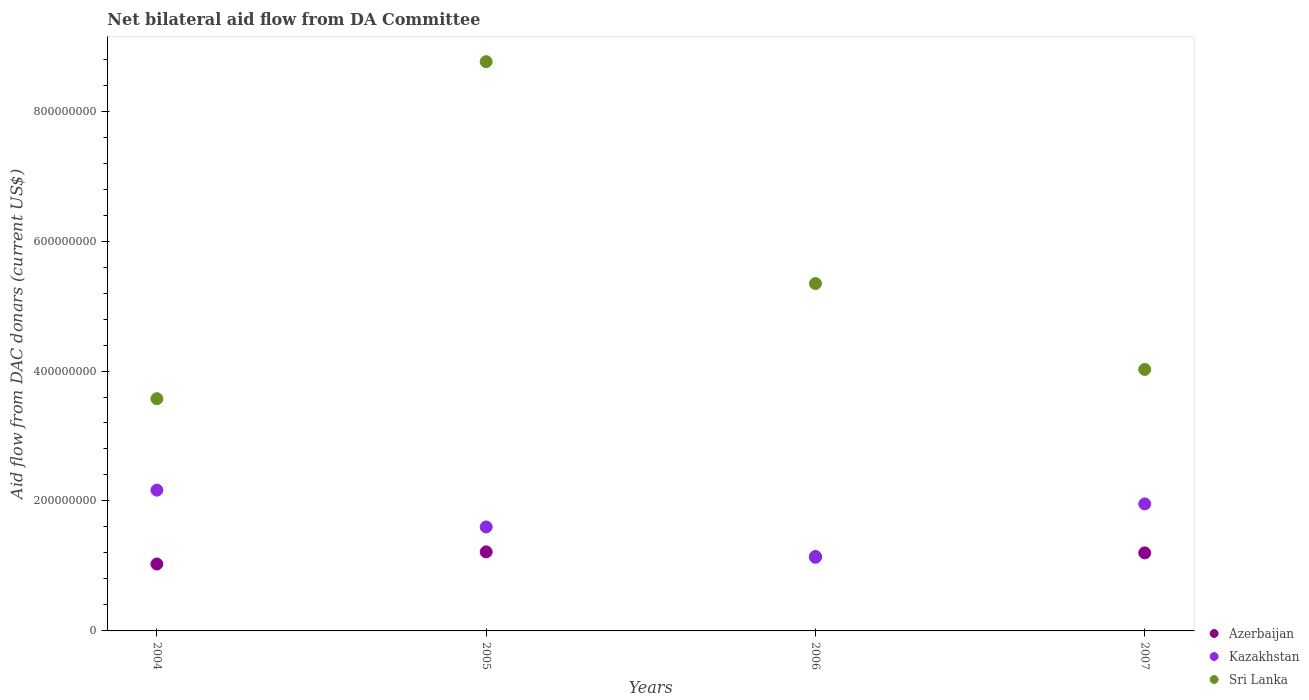How many different coloured dotlines are there?
Your answer should be compact. 3. Is the number of dotlines equal to the number of legend labels?
Keep it short and to the point. Yes. What is the aid flow in in Sri Lanka in 2007?
Give a very brief answer. 4.02e+08. Across all years, what is the maximum aid flow in in Kazakhstan?
Make the answer very short. 2.17e+08. Across all years, what is the minimum aid flow in in Kazakhstan?
Your answer should be very brief. 1.13e+08. What is the total aid flow in in Kazakhstan in the graph?
Your answer should be compact. 6.85e+08. What is the difference between the aid flow in in Azerbaijan in 2004 and that in 2007?
Your response must be concise. -1.71e+07. What is the difference between the aid flow in in Azerbaijan in 2006 and the aid flow in in Sri Lanka in 2007?
Your answer should be very brief. -2.88e+08. What is the average aid flow in in Sri Lanka per year?
Your response must be concise. 5.43e+08. In the year 2004, what is the difference between the aid flow in in Kazakhstan and aid flow in in Sri Lanka?
Offer a very short reply. -1.41e+08. In how many years, is the aid flow in in Kazakhstan greater than 360000000 US$?
Ensure brevity in your answer.  0. What is the ratio of the aid flow in in Sri Lanka in 2005 to that in 2006?
Offer a terse response. 1.64. Is the difference between the aid flow in in Kazakhstan in 2006 and 2007 greater than the difference between the aid flow in in Sri Lanka in 2006 and 2007?
Your answer should be very brief. No. What is the difference between the highest and the second highest aid flow in in Kazakhstan?
Keep it short and to the point. 2.12e+07. What is the difference between the highest and the lowest aid flow in in Azerbaijan?
Keep it short and to the point. 1.87e+07. In how many years, is the aid flow in in Kazakhstan greater than the average aid flow in in Kazakhstan taken over all years?
Offer a terse response. 2. Does the aid flow in in Sri Lanka monotonically increase over the years?
Offer a very short reply. No. Is the aid flow in in Sri Lanka strictly greater than the aid flow in in Azerbaijan over the years?
Your answer should be very brief. Yes. Is the aid flow in in Azerbaijan strictly less than the aid flow in in Sri Lanka over the years?
Keep it short and to the point. Yes. How many years are there in the graph?
Give a very brief answer. 4. What is the difference between two consecutive major ticks on the Y-axis?
Provide a succinct answer. 2.00e+08. Are the values on the major ticks of Y-axis written in scientific E-notation?
Provide a short and direct response. No. Does the graph contain any zero values?
Keep it short and to the point. No. Does the graph contain grids?
Keep it short and to the point. No. How many legend labels are there?
Provide a succinct answer. 3. How are the legend labels stacked?
Ensure brevity in your answer.  Vertical. What is the title of the graph?
Provide a succinct answer. Net bilateral aid flow from DA Committee. What is the label or title of the Y-axis?
Keep it short and to the point. Aid flow from DAC donars (current US$). What is the Aid flow from DAC donars (current US$) in Azerbaijan in 2004?
Your response must be concise. 1.03e+08. What is the Aid flow from DAC donars (current US$) of Kazakhstan in 2004?
Provide a succinct answer. 2.17e+08. What is the Aid flow from DAC donars (current US$) in Sri Lanka in 2004?
Provide a succinct answer. 3.57e+08. What is the Aid flow from DAC donars (current US$) of Azerbaijan in 2005?
Provide a short and direct response. 1.22e+08. What is the Aid flow from DAC donars (current US$) of Kazakhstan in 2005?
Give a very brief answer. 1.60e+08. What is the Aid flow from DAC donars (current US$) in Sri Lanka in 2005?
Offer a terse response. 8.76e+08. What is the Aid flow from DAC donars (current US$) of Azerbaijan in 2006?
Provide a short and direct response. 1.14e+08. What is the Aid flow from DAC donars (current US$) of Kazakhstan in 2006?
Your answer should be compact. 1.13e+08. What is the Aid flow from DAC donars (current US$) of Sri Lanka in 2006?
Your response must be concise. 5.35e+08. What is the Aid flow from DAC donars (current US$) in Azerbaijan in 2007?
Ensure brevity in your answer.  1.20e+08. What is the Aid flow from DAC donars (current US$) in Kazakhstan in 2007?
Provide a short and direct response. 1.95e+08. What is the Aid flow from DAC donars (current US$) in Sri Lanka in 2007?
Offer a terse response. 4.02e+08. Across all years, what is the maximum Aid flow from DAC donars (current US$) of Azerbaijan?
Keep it short and to the point. 1.22e+08. Across all years, what is the maximum Aid flow from DAC donars (current US$) of Kazakhstan?
Offer a very short reply. 2.17e+08. Across all years, what is the maximum Aid flow from DAC donars (current US$) of Sri Lanka?
Give a very brief answer. 8.76e+08. Across all years, what is the minimum Aid flow from DAC donars (current US$) of Azerbaijan?
Offer a very short reply. 1.03e+08. Across all years, what is the minimum Aid flow from DAC donars (current US$) in Kazakhstan?
Offer a very short reply. 1.13e+08. Across all years, what is the minimum Aid flow from DAC donars (current US$) in Sri Lanka?
Offer a very short reply. 3.57e+08. What is the total Aid flow from DAC donars (current US$) of Azerbaijan in the graph?
Offer a very short reply. 4.59e+08. What is the total Aid flow from DAC donars (current US$) of Kazakhstan in the graph?
Make the answer very short. 6.85e+08. What is the total Aid flow from DAC donars (current US$) in Sri Lanka in the graph?
Provide a short and direct response. 2.17e+09. What is the difference between the Aid flow from DAC donars (current US$) in Azerbaijan in 2004 and that in 2005?
Provide a short and direct response. -1.87e+07. What is the difference between the Aid flow from DAC donars (current US$) in Kazakhstan in 2004 and that in 2005?
Give a very brief answer. 5.66e+07. What is the difference between the Aid flow from DAC donars (current US$) in Sri Lanka in 2004 and that in 2005?
Your answer should be very brief. -5.19e+08. What is the difference between the Aid flow from DAC donars (current US$) of Azerbaijan in 2004 and that in 2006?
Offer a very short reply. -1.14e+07. What is the difference between the Aid flow from DAC donars (current US$) of Kazakhstan in 2004 and that in 2006?
Ensure brevity in your answer.  1.03e+08. What is the difference between the Aid flow from DAC donars (current US$) of Sri Lanka in 2004 and that in 2006?
Give a very brief answer. -1.77e+08. What is the difference between the Aid flow from DAC donars (current US$) of Azerbaijan in 2004 and that in 2007?
Your answer should be very brief. -1.71e+07. What is the difference between the Aid flow from DAC donars (current US$) of Kazakhstan in 2004 and that in 2007?
Ensure brevity in your answer.  2.12e+07. What is the difference between the Aid flow from DAC donars (current US$) in Sri Lanka in 2004 and that in 2007?
Keep it short and to the point. -4.50e+07. What is the difference between the Aid flow from DAC donars (current US$) of Azerbaijan in 2005 and that in 2006?
Your answer should be compact. 7.27e+06. What is the difference between the Aid flow from DAC donars (current US$) in Kazakhstan in 2005 and that in 2006?
Offer a very short reply. 4.67e+07. What is the difference between the Aid flow from DAC donars (current US$) in Sri Lanka in 2005 and that in 2006?
Your response must be concise. 3.41e+08. What is the difference between the Aid flow from DAC donars (current US$) in Azerbaijan in 2005 and that in 2007?
Make the answer very short. 1.55e+06. What is the difference between the Aid flow from DAC donars (current US$) of Kazakhstan in 2005 and that in 2007?
Make the answer very short. -3.54e+07. What is the difference between the Aid flow from DAC donars (current US$) of Sri Lanka in 2005 and that in 2007?
Keep it short and to the point. 4.74e+08. What is the difference between the Aid flow from DAC donars (current US$) of Azerbaijan in 2006 and that in 2007?
Your answer should be very brief. -5.72e+06. What is the difference between the Aid flow from DAC donars (current US$) of Kazakhstan in 2006 and that in 2007?
Offer a terse response. -8.22e+07. What is the difference between the Aid flow from DAC donars (current US$) in Sri Lanka in 2006 and that in 2007?
Provide a short and direct response. 1.32e+08. What is the difference between the Aid flow from DAC donars (current US$) in Azerbaijan in 2004 and the Aid flow from DAC donars (current US$) in Kazakhstan in 2005?
Offer a very short reply. -5.71e+07. What is the difference between the Aid flow from DAC donars (current US$) of Azerbaijan in 2004 and the Aid flow from DAC donars (current US$) of Sri Lanka in 2005?
Keep it short and to the point. -7.73e+08. What is the difference between the Aid flow from DAC donars (current US$) of Kazakhstan in 2004 and the Aid flow from DAC donars (current US$) of Sri Lanka in 2005?
Give a very brief answer. -6.59e+08. What is the difference between the Aid flow from DAC donars (current US$) of Azerbaijan in 2004 and the Aid flow from DAC donars (current US$) of Kazakhstan in 2006?
Your response must be concise. -1.03e+07. What is the difference between the Aid flow from DAC donars (current US$) of Azerbaijan in 2004 and the Aid flow from DAC donars (current US$) of Sri Lanka in 2006?
Keep it short and to the point. -4.32e+08. What is the difference between the Aid flow from DAC donars (current US$) in Kazakhstan in 2004 and the Aid flow from DAC donars (current US$) in Sri Lanka in 2006?
Make the answer very short. -3.18e+08. What is the difference between the Aid flow from DAC donars (current US$) of Azerbaijan in 2004 and the Aid flow from DAC donars (current US$) of Kazakhstan in 2007?
Your answer should be compact. -9.25e+07. What is the difference between the Aid flow from DAC donars (current US$) of Azerbaijan in 2004 and the Aid flow from DAC donars (current US$) of Sri Lanka in 2007?
Provide a succinct answer. -2.99e+08. What is the difference between the Aid flow from DAC donars (current US$) of Kazakhstan in 2004 and the Aid flow from DAC donars (current US$) of Sri Lanka in 2007?
Your response must be concise. -1.86e+08. What is the difference between the Aid flow from DAC donars (current US$) in Azerbaijan in 2005 and the Aid flow from DAC donars (current US$) in Kazakhstan in 2006?
Ensure brevity in your answer.  8.35e+06. What is the difference between the Aid flow from DAC donars (current US$) of Azerbaijan in 2005 and the Aid flow from DAC donars (current US$) of Sri Lanka in 2006?
Your response must be concise. -4.13e+08. What is the difference between the Aid flow from DAC donars (current US$) of Kazakhstan in 2005 and the Aid flow from DAC donars (current US$) of Sri Lanka in 2006?
Offer a terse response. -3.75e+08. What is the difference between the Aid flow from DAC donars (current US$) in Azerbaijan in 2005 and the Aid flow from DAC donars (current US$) in Kazakhstan in 2007?
Make the answer very short. -7.38e+07. What is the difference between the Aid flow from DAC donars (current US$) in Azerbaijan in 2005 and the Aid flow from DAC donars (current US$) in Sri Lanka in 2007?
Offer a very short reply. -2.81e+08. What is the difference between the Aid flow from DAC donars (current US$) of Kazakhstan in 2005 and the Aid flow from DAC donars (current US$) of Sri Lanka in 2007?
Give a very brief answer. -2.42e+08. What is the difference between the Aid flow from DAC donars (current US$) in Azerbaijan in 2006 and the Aid flow from DAC donars (current US$) in Kazakhstan in 2007?
Ensure brevity in your answer.  -8.11e+07. What is the difference between the Aid flow from DAC donars (current US$) of Azerbaijan in 2006 and the Aid flow from DAC donars (current US$) of Sri Lanka in 2007?
Provide a succinct answer. -2.88e+08. What is the difference between the Aid flow from DAC donars (current US$) of Kazakhstan in 2006 and the Aid flow from DAC donars (current US$) of Sri Lanka in 2007?
Provide a short and direct response. -2.89e+08. What is the average Aid flow from DAC donars (current US$) in Azerbaijan per year?
Keep it short and to the point. 1.15e+08. What is the average Aid flow from DAC donars (current US$) of Kazakhstan per year?
Provide a succinct answer. 1.71e+08. What is the average Aid flow from DAC donars (current US$) of Sri Lanka per year?
Ensure brevity in your answer.  5.43e+08. In the year 2004, what is the difference between the Aid flow from DAC donars (current US$) in Azerbaijan and Aid flow from DAC donars (current US$) in Kazakhstan?
Make the answer very short. -1.14e+08. In the year 2004, what is the difference between the Aid flow from DAC donars (current US$) of Azerbaijan and Aid flow from DAC donars (current US$) of Sri Lanka?
Ensure brevity in your answer.  -2.54e+08. In the year 2004, what is the difference between the Aid flow from DAC donars (current US$) of Kazakhstan and Aid flow from DAC donars (current US$) of Sri Lanka?
Give a very brief answer. -1.41e+08. In the year 2005, what is the difference between the Aid flow from DAC donars (current US$) in Azerbaijan and Aid flow from DAC donars (current US$) in Kazakhstan?
Your response must be concise. -3.84e+07. In the year 2005, what is the difference between the Aid flow from DAC donars (current US$) of Azerbaijan and Aid flow from DAC donars (current US$) of Sri Lanka?
Your response must be concise. -7.54e+08. In the year 2005, what is the difference between the Aid flow from DAC donars (current US$) in Kazakhstan and Aid flow from DAC donars (current US$) in Sri Lanka?
Offer a terse response. -7.16e+08. In the year 2006, what is the difference between the Aid flow from DAC donars (current US$) of Azerbaijan and Aid flow from DAC donars (current US$) of Kazakhstan?
Provide a short and direct response. 1.08e+06. In the year 2006, what is the difference between the Aid flow from DAC donars (current US$) in Azerbaijan and Aid flow from DAC donars (current US$) in Sri Lanka?
Offer a terse response. -4.20e+08. In the year 2006, what is the difference between the Aid flow from DAC donars (current US$) of Kazakhstan and Aid flow from DAC donars (current US$) of Sri Lanka?
Ensure brevity in your answer.  -4.21e+08. In the year 2007, what is the difference between the Aid flow from DAC donars (current US$) of Azerbaijan and Aid flow from DAC donars (current US$) of Kazakhstan?
Offer a terse response. -7.54e+07. In the year 2007, what is the difference between the Aid flow from DAC donars (current US$) of Azerbaijan and Aid flow from DAC donars (current US$) of Sri Lanka?
Your answer should be compact. -2.82e+08. In the year 2007, what is the difference between the Aid flow from DAC donars (current US$) in Kazakhstan and Aid flow from DAC donars (current US$) in Sri Lanka?
Offer a very short reply. -2.07e+08. What is the ratio of the Aid flow from DAC donars (current US$) in Azerbaijan in 2004 to that in 2005?
Provide a succinct answer. 0.85. What is the ratio of the Aid flow from DAC donars (current US$) in Kazakhstan in 2004 to that in 2005?
Your answer should be compact. 1.35. What is the ratio of the Aid flow from DAC donars (current US$) in Sri Lanka in 2004 to that in 2005?
Keep it short and to the point. 0.41. What is the ratio of the Aid flow from DAC donars (current US$) in Azerbaijan in 2004 to that in 2006?
Keep it short and to the point. 0.9. What is the ratio of the Aid flow from DAC donars (current US$) of Kazakhstan in 2004 to that in 2006?
Ensure brevity in your answer.  1.91. What is the ratio of the Aid flow from DAC donars (current US$) in Sri Lanka in 2004 to that in 2006?
Your response must be concise. 0.67. What is the ratio of the Aid flow from DAC donars (current US$) of Azerbaijan in 2004 to that in 2007?
Offer a very short reply. 0.86. What is the ratio of the Aid flow from DAC donars (current US$) in Kazakhstan in 2004 to that in 2007?
Make the answer very short. 1.11. What is the ratio of the Aid flow from DAC donars (current US$) in Sri Lanka in 2004 to that in 2007?
Offer a terse response. 0.89. What is the ratio of the Aid flow from DAC donars (current US$) in Azerbaijan in 2005 to that in 2006?
Give a very brief answer. 1.06. What is the ratio of the Aid flow from DAC donars (current US$) of Kazakhstan in 2005 to that in 2006?
Provide a short and direct response. 1.41. What is the ratio of the Aid flow from DAC donars (current US$) of Sri Lanka in 2005 to that in 2006?
Your answer should be very brief. 1.64. What is the ratio of the Aid flow from DAC donars (current US$) in Azerbaijan in 2005 to that in 2007?
Provide a short and direct response. 1.01. What is the ratio of the Aid flow from DAC donars (current US$) of Kazakhstan in 2005 to that in 2007?
Offer a terse response. 0.82. What is the ratio of the Aid flow from DAC donars (current US$) in Sri Lanka in 2005 to that in 2007?
Provide a short and direct response. 2.18. What is the ratio of the Aid flow from DAC donars (current US$) of Azerbaijan in 2006 to that in 2007?
Your response must be concise. 0.95. What is the ratio of the Aid flow from DAC donars (current US$) of Kazakhstan in 2006 to that in 2007?
Provide a short and direct response. 0.58. What is the ratio of the Aid flow from DAC donars (current US$) of Sri Lanka in 2006 to that in 2007?
Provide a short and direct response. 1.33. What is the difference between the highest and the second highest Aid flow from DAC donars (current US$) in Azerbaijan?
Your answer should be very brief. 1.55e+06. What is the difference between the highest and the second highest Aid flow from DAC donars (current US$) in Kazakhstan?
Provide a succinct answer. 2.12e+07. What is the difference between the highest and the second highest Aid flow from DAC donars (current US$) in Sri Lanka?
Provide a short and direct response. 3.41e+08. What is the difference between the highest and the lowest Aid flow from DAC donars (current US$) in Azerbaijan?
Provide a succinct answer. 1.87e+07. What is the difference between the highest and the lowest Aid flow from DAC donars (current US$) of Kazakhstan?
Give a very brief answer. 1.03e+08. What is the difference between the highest and the lowest Aid flow from DAC donars (current US$) of Sri Lanka?
Provide a succinct answer. 5.19e+08. 